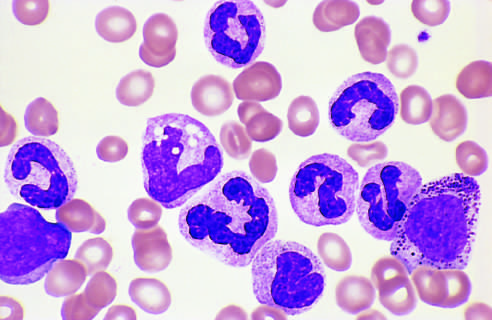re granulocytic forms at various stages of differentiation presented?
Answer the question using a single word or phrase. Yes 